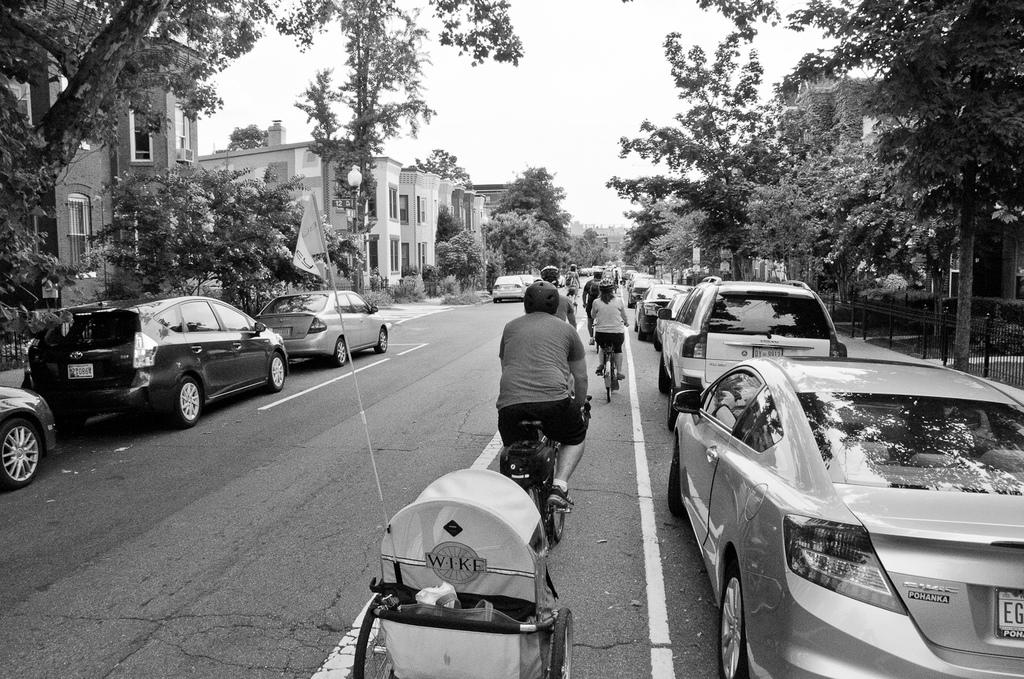What is the color scheme of the image? The image is black and white. What are the persons in the image doing? The persons in the image are riding bicycles on the road. What is the baby pram used for? The baby pram is used for transporting a baby. What else can be seen on the road besides bicycles? Motor vehicles are present on the road. What type of structures are visible in the image? There are buildings in the image. What natural elements can be seen in the image? Trees and the sky are visible in the image. What type of church can be seen in the image? There is no church present in the image. What badge is the person wearing on their bicycle? There is no badge visible on any of the persons riding bicycles in the image. 